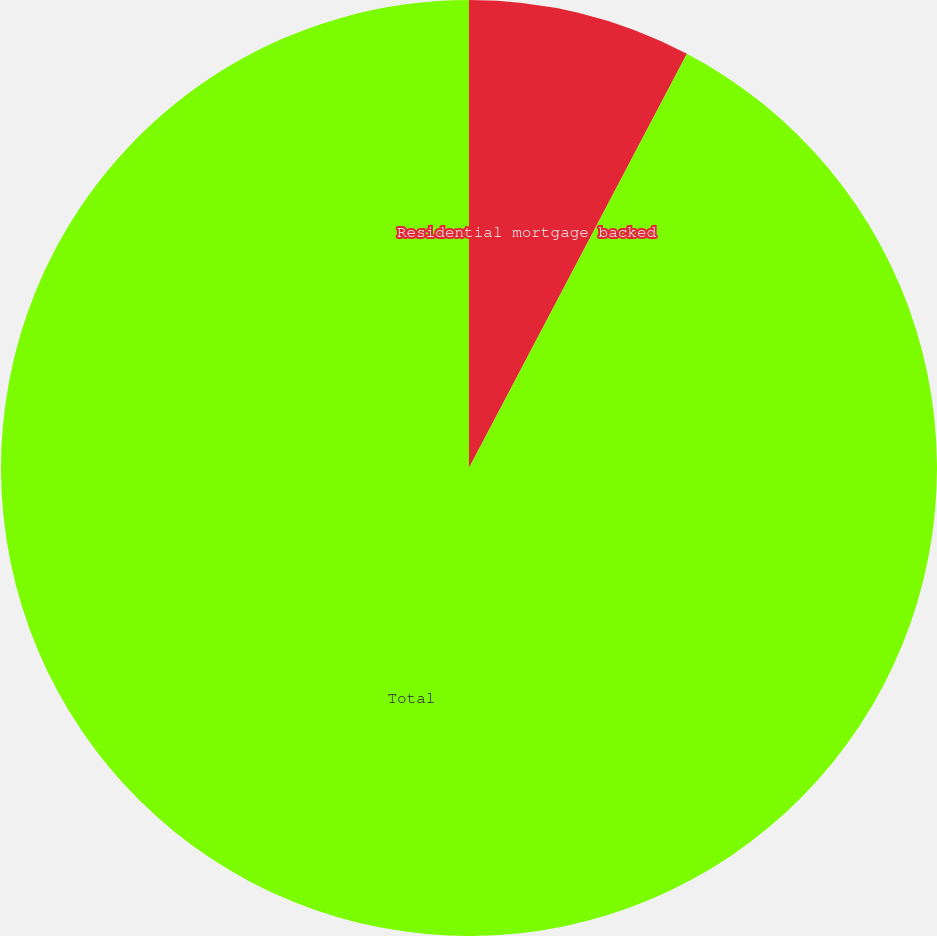Convert chart to OTSL. <chart><loc_0><loc_0><loc_500><loc_500><pie_chart><fcel>Residential mortgage backed<fcel>Total<nl><fcel>7.71%<fcel>92.29%<nl></chart> 